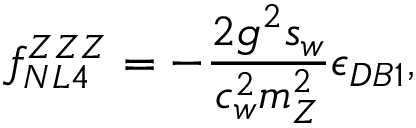Convert formula to latex. <formula><loc_0><loc_0><loc_500><loc_500>f _ { N L 4 } ^ { Z Z Z } = - \frac { 2 g ^ { 2 } s _ { w } } { c _ { w } ^ { 2 } m _ { Z } ^ { 2 } } \epsilon _ { D B 1 } ,</formula> 